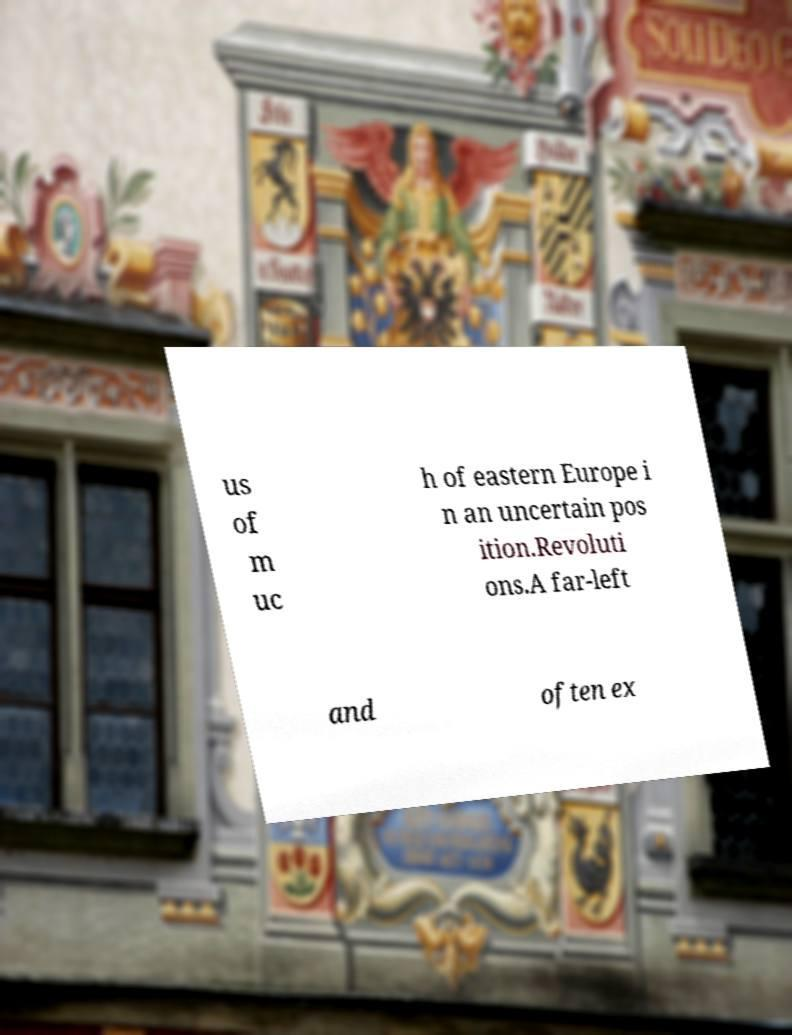Can you read and provide the text displayed in the image?This photo seems to have some interesting text. Can you extract and type it out for me? us of m uc h of eastern Europe i n an uncertain pos ition.Revoluti ons.A far-left and often ex 